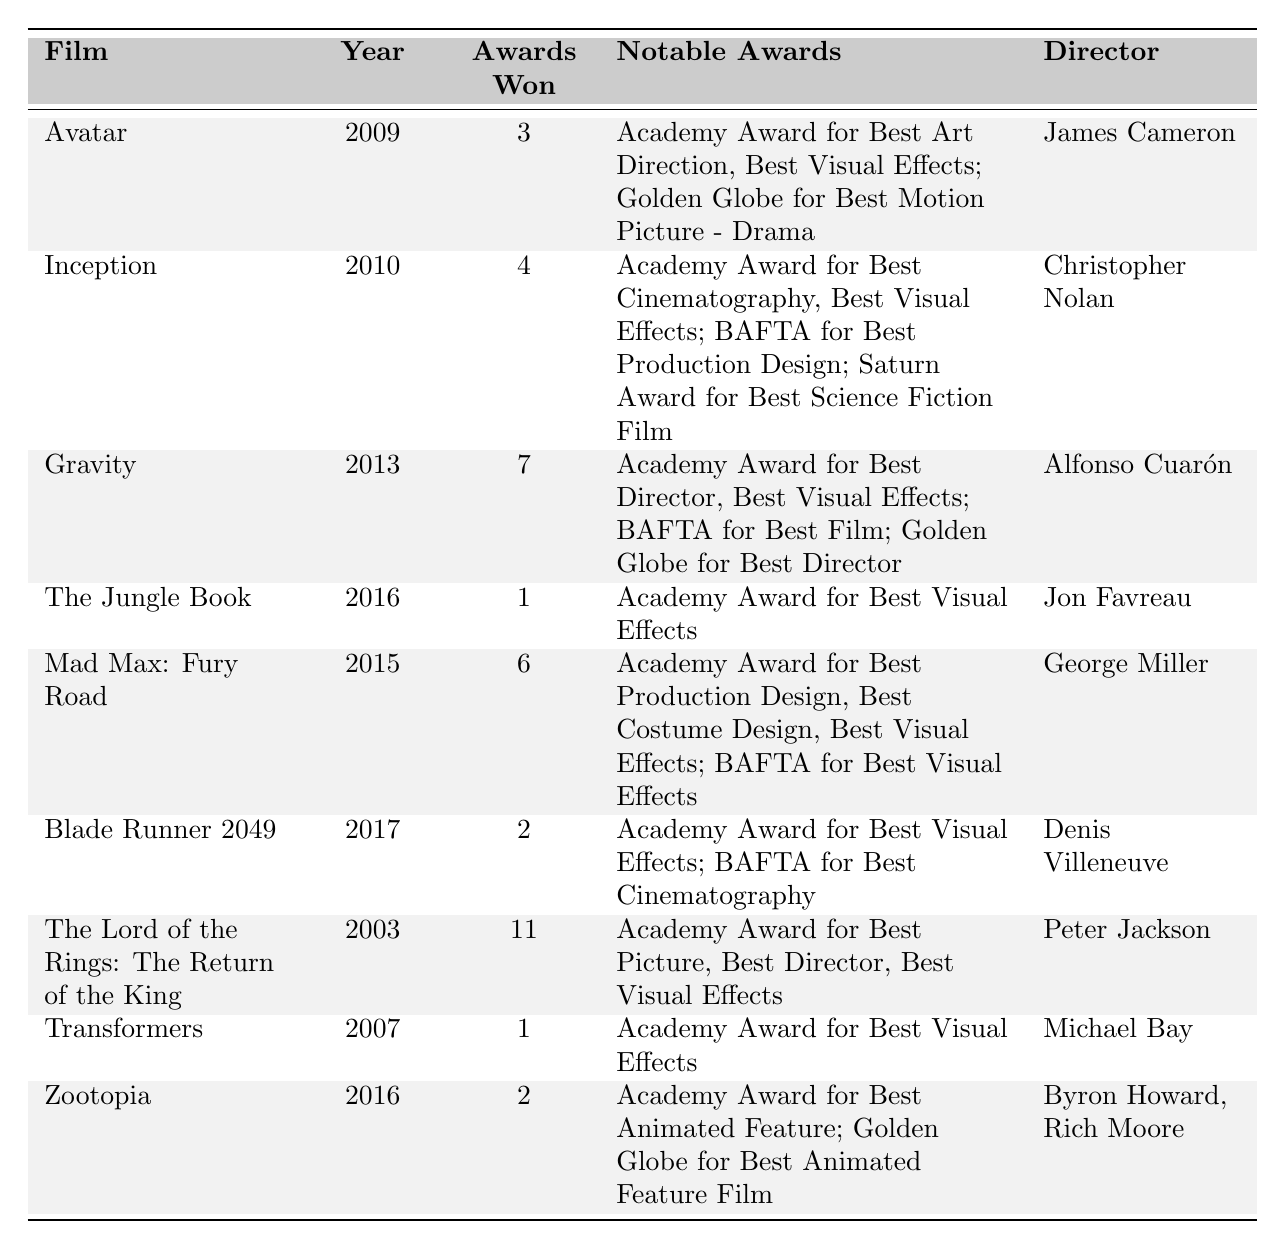What film directed by Alfonso Cuarón won the most awards? The table shows that "Gravity," directed by Alfonso Cuarón in 2013, won a total of 7 awards, which is the highest number of awards among the films listed.
Answer: Gravity Which film won 11 awards and who was its director? According to the table, "The Lord of the Rings: The Return of the King" won 11 awards, and its director was Peter Jackson.
Answer: Peter Jackson Did "Avatar" win more or fewer awards than "Mad Max: Fury Road"? "Avatar" won 3 awards, while "Mad Max: Fury Road" won 6 awards. Therefore, "Avatar" won fewer awards than "Mad Max: Fury Road."
Answer: Fewer What is the total number of awards won by films directed by Christopher Nolan and Alfonso Cuarón combined? "Inception," directed by Christopher Nolan, won 4 awards, while "Gravity," directed by Alfonso Cuarón, won 7 awards. Adding them together (4 + 7) equals 11 awards in total.
Answer: 11 Which film won the Academy Award for Best Picture, and how many awards did it win? The table indicates that "The Lord of the Rings: The Return of the King" won the Academy Award for Best Picture and it won a total of 11 awards.
Answer: 11 awards How many films listed won the Academy Award for Best Visual Effects? By reviewing the table, we find that "Avatar," "Inception," "Gravity," "The Jungle Book," "Mad Max: Fury Road," "Blade Runner 2049," and "Transformers" each won the Academy Award for Best Visual Effects. Counting them, we see that there are 7 films that won this award.
Answer: 7 Is it true that "Zootopia" won more awards than "Blade Runner 2049"? "Zootopia" won 2 awards while "Blade Runner 2049" won 2 awards as well. Therefore, the statement is false; they won the same number of awards.
Answer: False Which film features the most notable awards, and how many does it have? "The Lord of the Rings: The Return of the King" has the most notable awards listed, specifically 3 notable awards (Best Picture, Best Director, Best Visual Effects).
Answer: 3 notable awards How many films listed were released after 2010? The films released after 2010 are "Gravity" (2013), "Mad Max: Fury Road" (2015), "The Jungle Book" (2016), and "Zootopia" (2016), totaling 4 films.
Answer: 4 films What is the difference in awards won between "Gravity" and "Inception"? "Gravity" has won 7 awards and "Inception" has won 4 awards. The difference is calculated by subtracting the awards of "Inception" from those of "Gravity" (7 - 4), which equals 3 awards.
Answer: 3 awards 